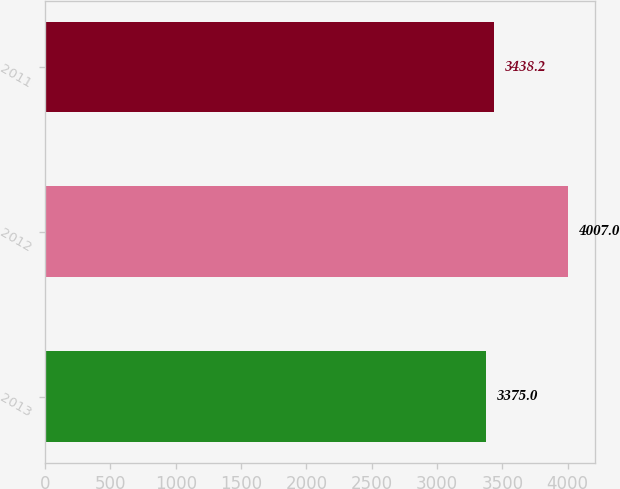<chart> <loc_0><loc_0><loc_500><loc_500><bar_chart><fcel>2013<fcel>2012<fcel>2011<nl><fcel>3375<fcel>4007<fcel>3438.2<nl></chart> 